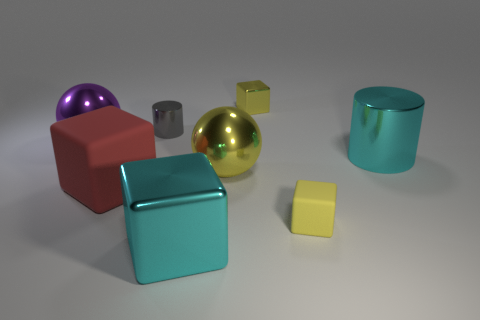Subtract all yellow rubber blocks. How many blocks are left? 3 Add 1 large cyan shiny cylinders. How many objects exist? 9 Subtract all red cubes. How many cubes are left? 3 Subtract all cylinders. How many objects are left? 6 Subtract 0 red spheres. How many objects are left? 8 Subtract 2 cubes. How many cubes are left? 2 Subtract all cyan cylinders. Subtract all red balls. How many cylinders are left? 1 Subtract all green cylinders. How many yellow blocks are left? 2 Subtract all tiny gray cylinders. Subtract all large cyan shiny things. How many objects are left? 5 Add 3 big metal cubes. How many big metal cubes are left? 4 